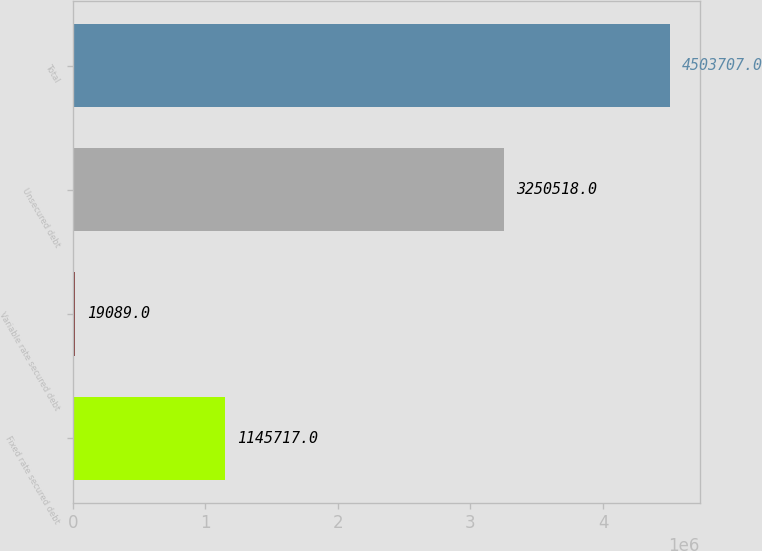Convert chart. <chart><loc_0><loc_0><loc_500><loc_500><bar_chart><fcel>Fixed rate secured debt<fcel>Variable rate secured debt<fcel>Unsecured debt<fcel>Total<nl><fcel>1.14572e+06<fcel>19089<fcel>3.25052e+06<fcel>4.50371e+06<nl></chart> 